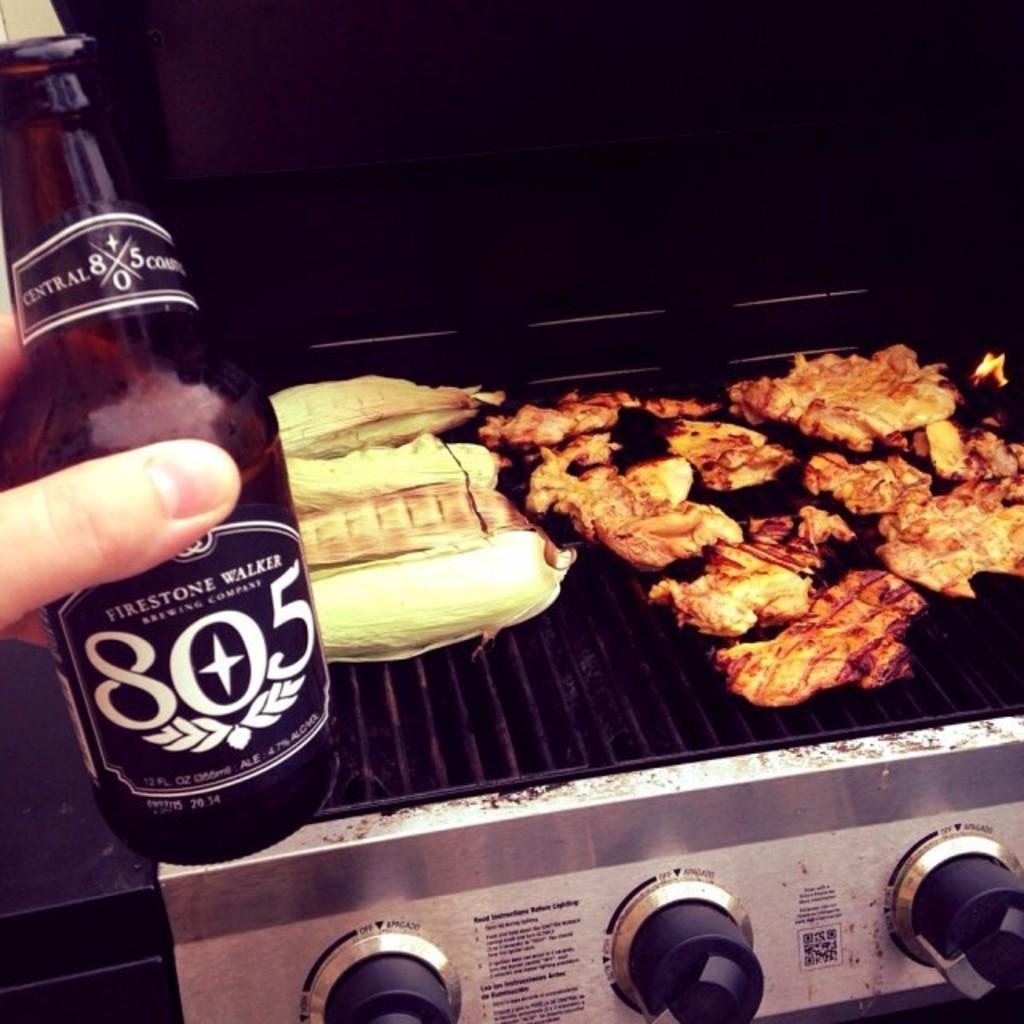<image>
Give a short and clear explanation of the subsequent image. A person holds up a bottle of Firestone Walker 805 in front of a grill. 